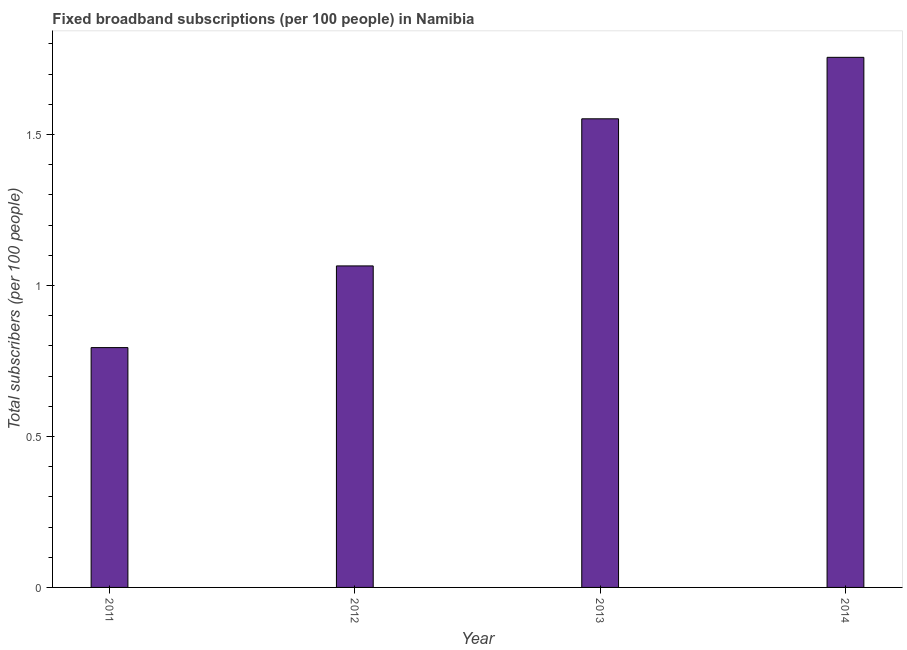What is the title of the graph?
Make the answer very short. Fixed broadband subscriptions (per 100 people) in Namibia. What is the label or title of the X-axis?
Offer a very short reply. Year. What is the label or title of the Y-axis?
Provide a short and direct response. Total subscribers (per 100 people). What is the total number of fixed broadband subscriptions in 2011?
Ensure brevity in your answer.  0.79. Across all years, what is the maximum total number of fixed broadband subscriptions?
Provide a short and direct response. 1.76. Across all years, what is the minimum total number of fixed broadband subscriptions?
Keep it short and to the point. 0.79. In which year was the total number of fixed broadband subscriptions maximum?
Make the answer very short. 2014. What is the sum of the total number of fixed broadband subscriptions?
Your response must be concise. 5.17. What is the difference between the total number of fixed broadband subscriptions in 2012 and 2014?
Offer a terse response. -0.69. What is the average total number of fixed broadband subscriptions per year?
Give a very brief answer. 1.29. What is the median total number of fixed broadband subscriptions?
Offer a very short reply. 1.31. What is the ratio of the total number of fixed broadband subscriptions in 2012 to that in 2014?
Your answer should be very brief. 0.61. Is the total number of fixed broadband subscriptions in 2011 less than that in 2013?
Your answer should be compact. Yes. What is the difference between the highest and the second highest total number of fixed broadband subscriptions?
Your answer should be very brief. 0.2. What is the difference between the highest and the lowest total number of fixed broadband subscriptions?
Provide a succinct answer. 0.96. In how many years, is the total number of fixed broadband subscriptions greater than the average total number of fixed broadband subscriptions taken over all years?
Offer a terse response. 2. How many years are there in the graph?
Offer a very short reply. 4. What is the difference between two consecutive major ticks on the Y-axis?
Ensure brevity in your answer.  0.5. Are the values on the major ticks of Y-axis written in scientific E-notation?
Make the answer very short. No. What is the Total subscribers (per 100 people) in 2011?
Your answer should be compact. 0.79. What is the Total subscribers (per 100 people) in 2012?
Your answer should be very brief. 1.06. What is the Total subscribers (per 100 people) in 2013?
Make the answer very short. 1.55. What is the Total subscribers (per 100 people) of 2014?
Ensure brevity in your answer.  1.76. What is the difference between the Total subscribers (per 100 people) in 2011 and 2012?
Make the answer very short. -0.27. What is the difference between the Total subscribers (per 100 people) in 2011 and 2013?
Make the answer very short. -0.76. What is the difference between the Total subscribers (per 100 people) in 2011 and 2014?
Give a very brief answer. -0.96. What is the difference between the Total subscribers (per 100 people) in 2012 and 2013?
Your answer should be compact. -0.49. What is the difference between the Total subscribers (per 100 people) in 2012 and 2014?
Provide a short and direct response. -0.69. What is the difference between the Total subscribers (per 100 people) in 2013 and 2014?
Give a very brief answer. -0.2. What is the ratio of the Total subscribers (per 100 people) in 2011 to that in 2012?
Provide a short and direct response. 0.75. What is the ratio of the Total subscribers (per 100 people) in 2011 to that in 2013?
Your response must be concise. 0.51. What is the ratio of the Total subscribers (per 100 people) in 2011 to that in 2014?
Offer a terse response. 0.45. What is the ratio of the Total subscribers (per 100 people) in 2012 to that in 2013?
Offer a terse response. 0.69. What is the ratio of the Total subscribers (per 100 people) in 2012 to that in 2014?
Ensure brevity in your answer.  0.61. What is the ratio of the Total subscribers (per 100 people) in 2013 to that in 2014?
Give a very brief answer. 0.88. 